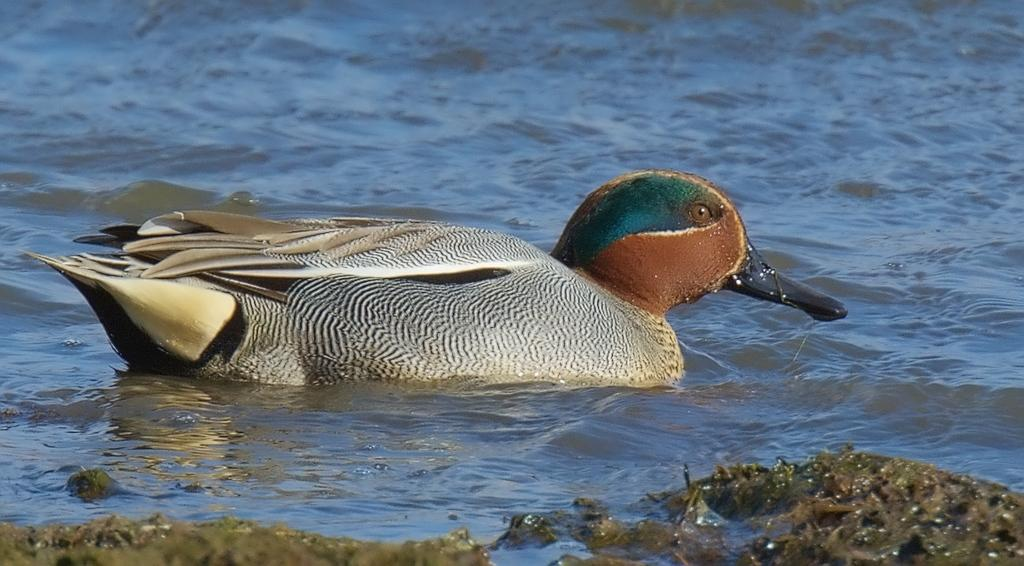What type of animal is in the image? There is a bird in the image. Where is the bird located? The bird is in the water. What is visible at the bottom of the image? There is sand at the bottom of the image. What type of protest is happening in the image? There is no protest present in the image; it features a bird in the water and sand at the bottom. Can you see a chessboard in the image? There is no chessboard present in the image. 